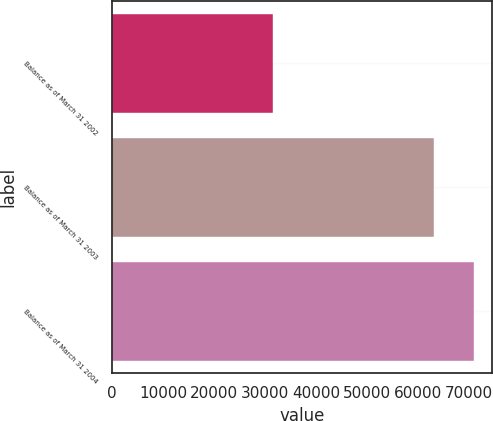Convert chart. <chart><loc_0><loc_0><loc_500><loc_500><bar_chart><fcel>Balance as of March 31 2002<fcel>Balance as of March 31 2003<fcel>Balance as of March 31 2004<nl><fcel>31626<fcel>63194<fcel>70898<nl></chart> 